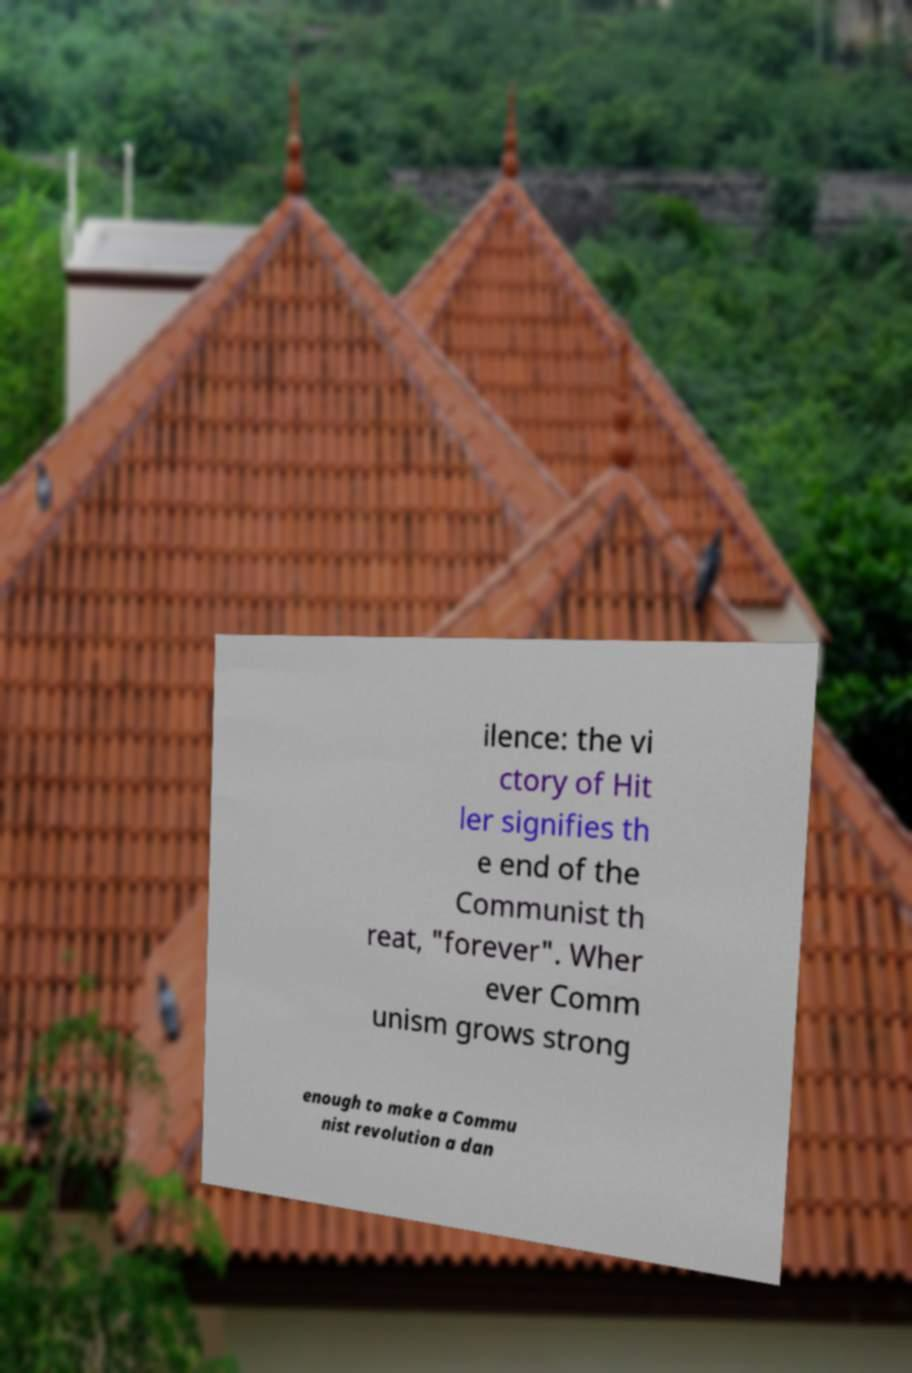For documentation purposes, I need the text within this image transcribed. Could you provide that? ilence: the vi ctory of Hit ler signifies th e end of the Communist th reat, "forever". Wher ever Comm unism grows strong enough to make a Commu nist revolution a dan 